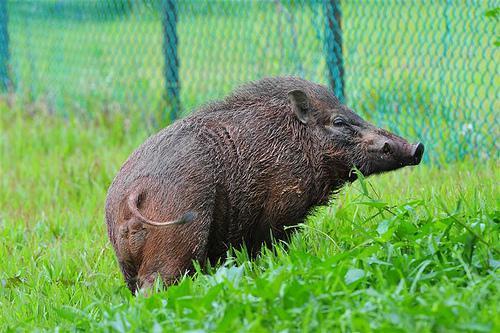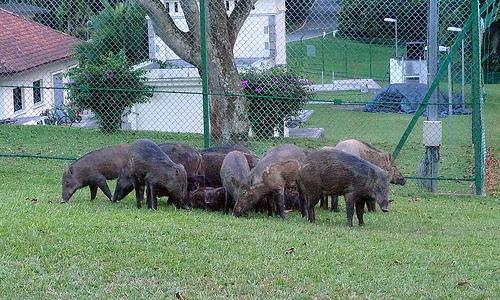The first image is the image on the left, the second image is the image on the right. For the images displayed, is the sentence "A single warthog is facing to the right while standing on green grass in one of the images.." factually correct? Answer yes or no. Yes. The first image is the image on the left, the second image is the image on the right. Analyze the images presented: Is the assertion "There is a hog standing in the grass in the left image" valid? Answer yes or no. Yes. 